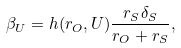Convert formula to latex. <formula><loc_0><loc_0><loc_500><loc_500>\beta _ { U } = h ( r _ { O } , U ) \frac { r _ { S } \delta _ { S } } { r _ { O } + r _ { S } } ,</formula> 